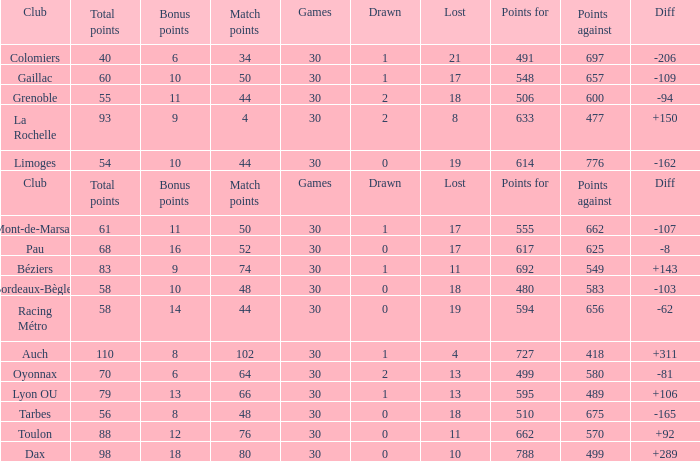What is the value of match points when the points for is 570? 76.0. 